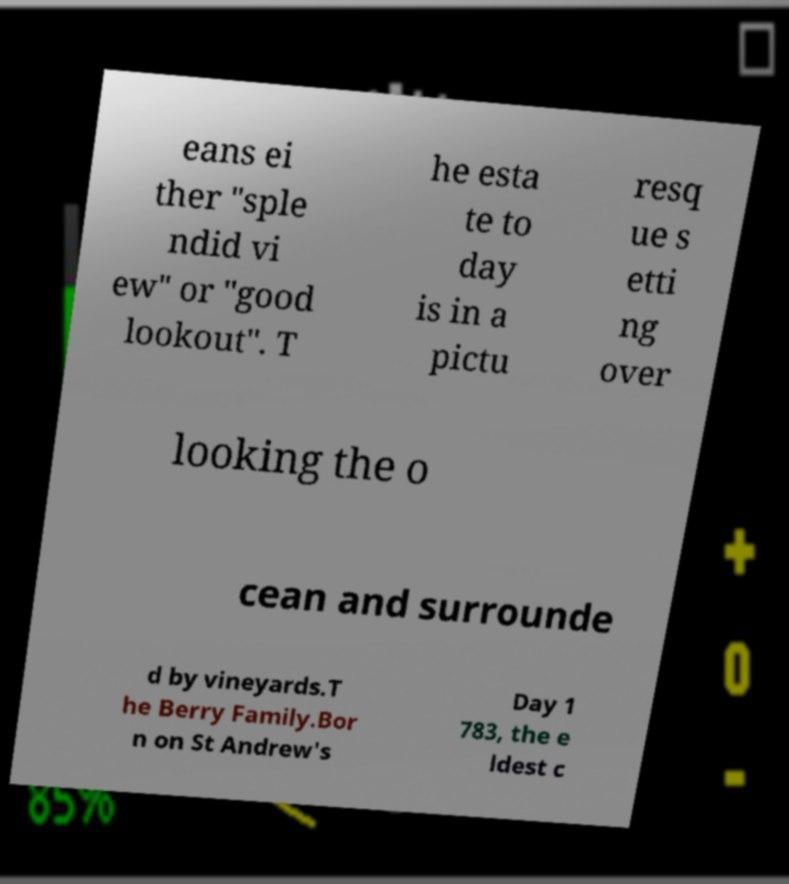Please read and relay the text visible in this image. What does it say? eans ei ther "sple ndid vi ew" or "good lookout". T he esta te to day is in a pictu resq ue s etti ng over looking the o cean and surrounde d by vineyards.T he Berry Family.Bor n on St Andrew's Day 1 783, the e ldest c 